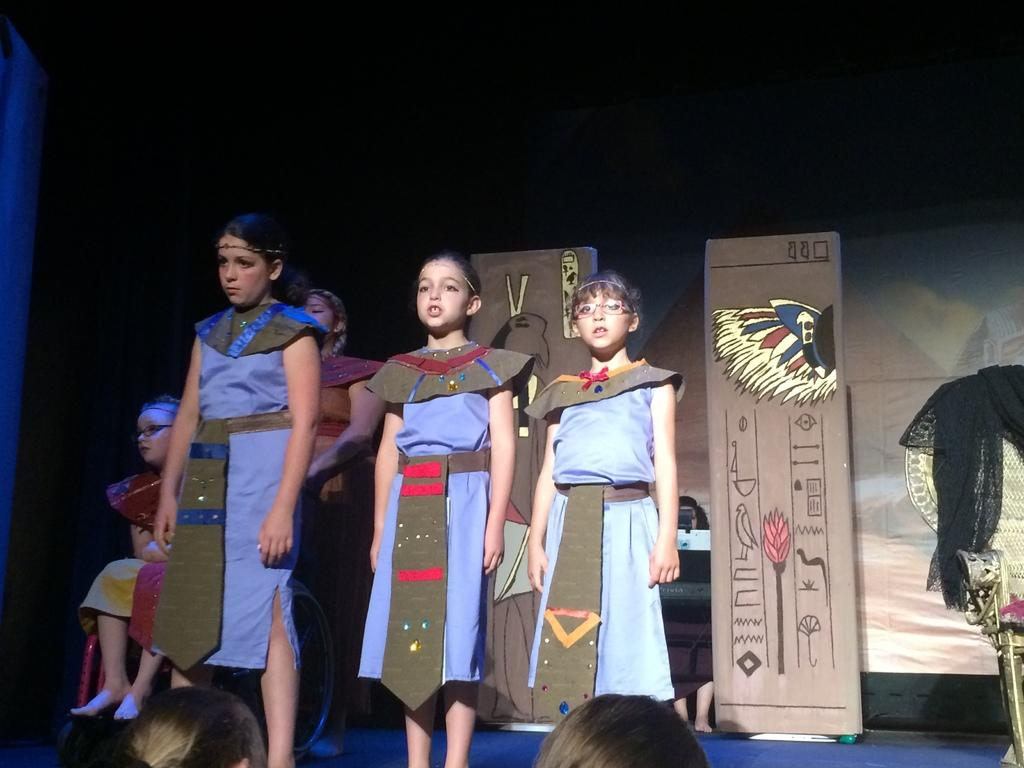What can be observed about the attire of the people in the image? There are people wearing different color dresses in the image. What can be seen in the background of the image? There are boards visible in the background. What is present on the stage in the image? There are objects on the stage. How would you describe the lighting in the image? The background is dark. What type of liquid can be seen flowing from the trees in the image? There are no trees present in the image, so there is no liquid flowing from them. How does the audience's hearing affect the performance in the image? The image does not depict a performance or an audience, so it is impossible to determine how their hearing might affect the performance. 